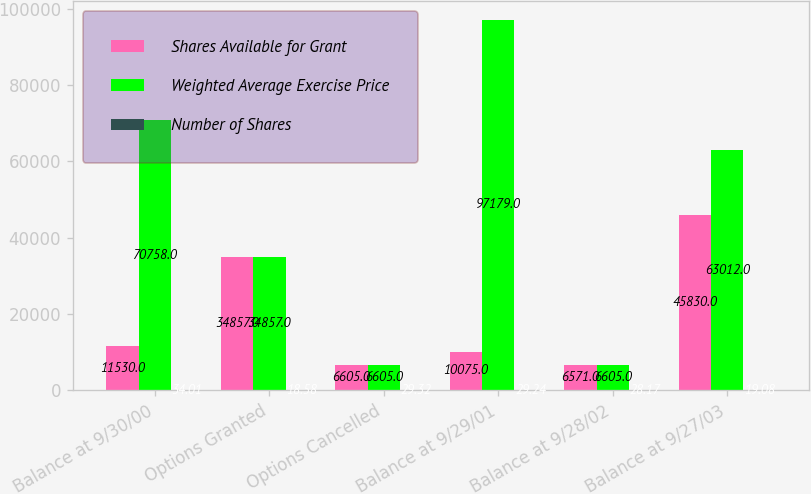Convert chart to OTSL. <chart><loc_0><loc_0><loc_500><loc_500><stacked_bar_chart><ecel><fcel>Balance at 9/30/00<fcel>Options Granted<fcel>Options Cancelled<fcel>Balance at 9/29/01<fcel>Balance at 9/28/02<fcel>Balance at 9/27/03<nl><fcel>Shares Available for Grant<fcel>11530<fcel>34857<fcel>6605<fcel>10075<fcel>6571<fcel>45830<nl><fcel>Weighted Average Exercise Price<fcel>70758<fcel>34857<fcel>6605<fcel>97179<fcel>6605<fcel>63012<nl><fcel>Number of Shares<fcel>34.01<fcel>18.58<fcel>29.32<fcel>29.24<fcel>28.17<fcel>19.08<nl></chart> 